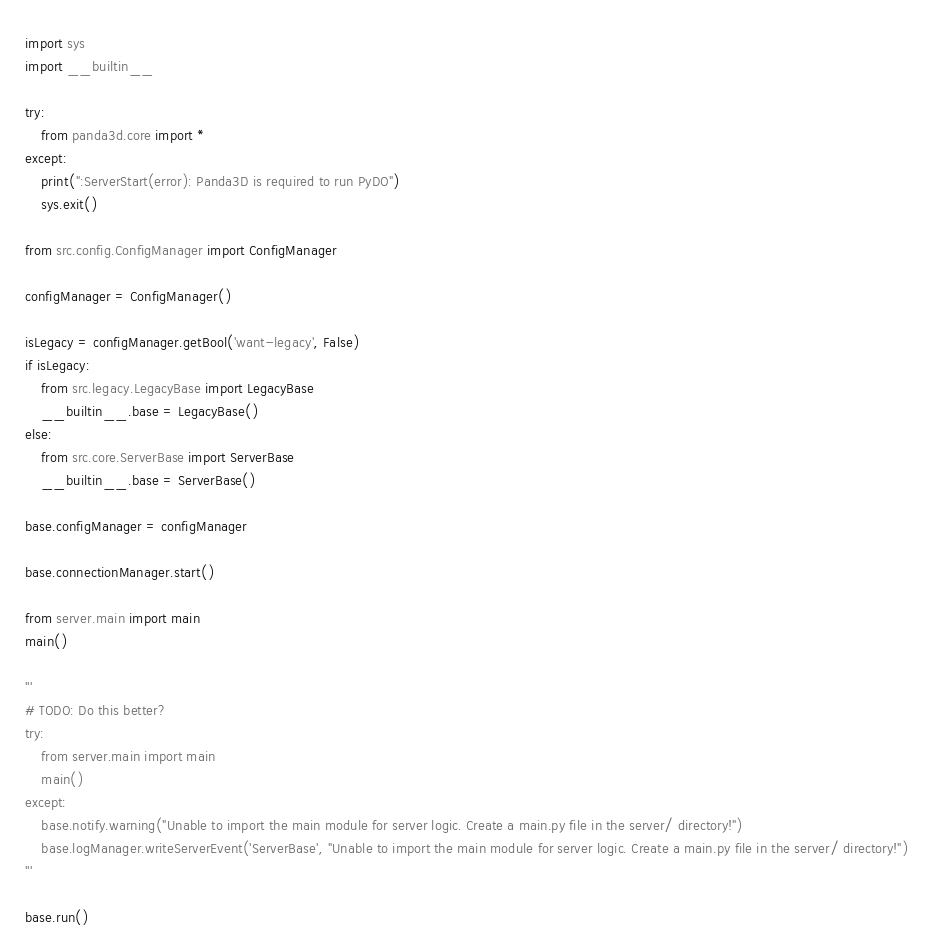<code> <loc_0><loc_0><loc_500><loc_500><_Python_>import sys
import __builtin__

try:
    from panda3d.core import *
except:
    print(":ServerStart(error): Panda3D is required to run PyDO")
    sys.exit()

from src.config.ConfigManager import ConfigManager

configManager = ConfigManager()

isLegacy = configManager.getBool('want-legacy', False)
if isLegacy:
    from src.legacy.LegacyBase import LegacyBase
    __builtin__.base = LegacyBase()
else:
    from src.core.ServerBase import ServerBase
    __builtin__.base = ServerBase()

base.configManager = configManager

base.connectionManager.start()

from server.main import main
main()

'''
# TODO: Do this better?
try:
	from server.main import main
	main()
except:
	base.notify.warning("Unable to import the main module for server logic. Create a main.py file in the server/ directory!")
	base.logManager.writeServerEvent('ServerBase', "Unable to import the main module for server logic. Create a main.py file in the server/ directory!")
'''

base.run()</code> 